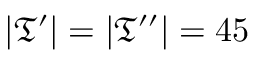<formula> <loc_0><loc_0><loc_500><loc_500>| \mathfrak { T } ^ { \prime } | = | \mathfrak { T } ^ { \prime \prime } | = 4 5</formula> 